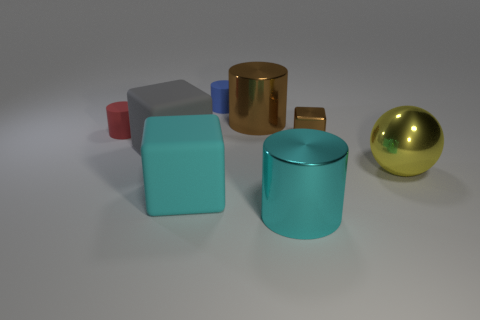What material is the large cyan object on the left side of the shiny cylinder in front of the red rubber thing made of?
Make the answer very short. Rubber. How big is the metal ball?
Keep it short and to the point. Large. The brown cylinder that is made of the same material as the big yellow thing is what size?
Give a very brief answer. Large. There is a brown shiny object that is to the left of the brown metal block; is its size the same as the small blue rubber cylinder?
Ensure brevity in your answer.  No. There is a tiny object right of the small rubber object that is right of the block that is in front of the gray cube; what shape is it?
Keep it short and to the point. Cube. What number of objects are blue matte objects or objects in front of the blue matte cylinder?
Keep it short and to the point. 8. There is a gray object in front of the red thing; what is its size?
Your answer should be compact. Large. What shape is the big shiny object that is the same color as the metallic cube?
Offer a very short reply. Cylinder. Are the red object and the large yellow sphere in front of the gray matte thing made of the same material?
Your answer should be compact. No. What number of tiny cylinders are in front of the brown object left of the metal thing in front of the large shiny sphere?
Offer a very short reply. 1. 